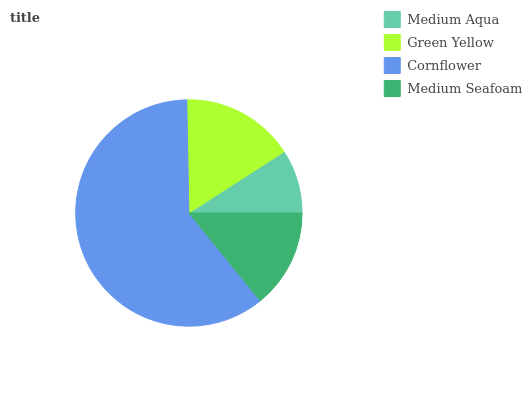Is Medium Aqua the minimum?
Answer yes or no. Yes. Is Cornflower the maximum?
Answer yes or no. Yes. Is Green Yellow the minimum?
Answer yes or no. No. Is Green Yellow the maximum?
Answer yes or no. No. Is Green Yellow greater than Medium Aqua?
Answer yes or no. Yes. Is Medium Aqua less than Green Yellow?
Answer yes or no. Yes. Is Medium Aqua greater than Green Yellow?
Answer yes or no. No. Is Green Yellow less than Medium Aqua?
Answer yes or no. No. Is Green Yellow the high median?
Answer yes or no. Yes. Is Medium Seafoam the low median?
Answer yes or no. Yes. Is Cornflower the high median?
Answer yes or no. No. Is Cornflower the low median?
Answer yes or no. No. 